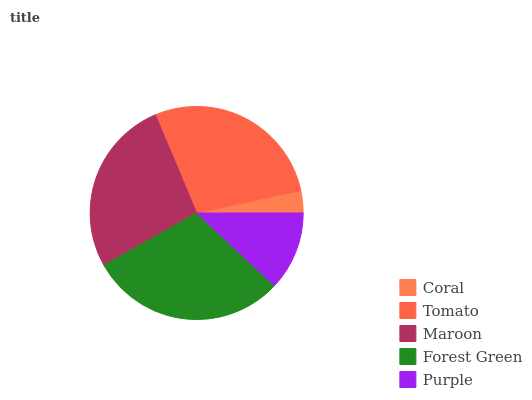Is Coral the minimum?
Answer yes or no. Yes. Is Forest Green the maximum?
Answer yes or no. Yes. Is Tomato the minimum?
Answer yes or no. No. Is Tomato the maximum?
Answer yes or no. No. Is Tomato greater than Coral?
Answer yes or no. Yes. Is Coral less than Tomato?
Answer yes or no. Yes. Is Coral greater than Tomato?
Answer yes or no. No. Is Tomato less than Coral?
Answer yes or no. No. Is Maroon the high median?
Answer yes or no. Yes. Is Maroon the low median?
Answer yes or no. Yes. Is Forest Green the high median?
Answer yes or no. No. Is Purple the low median?
Answer yes or no. No. 